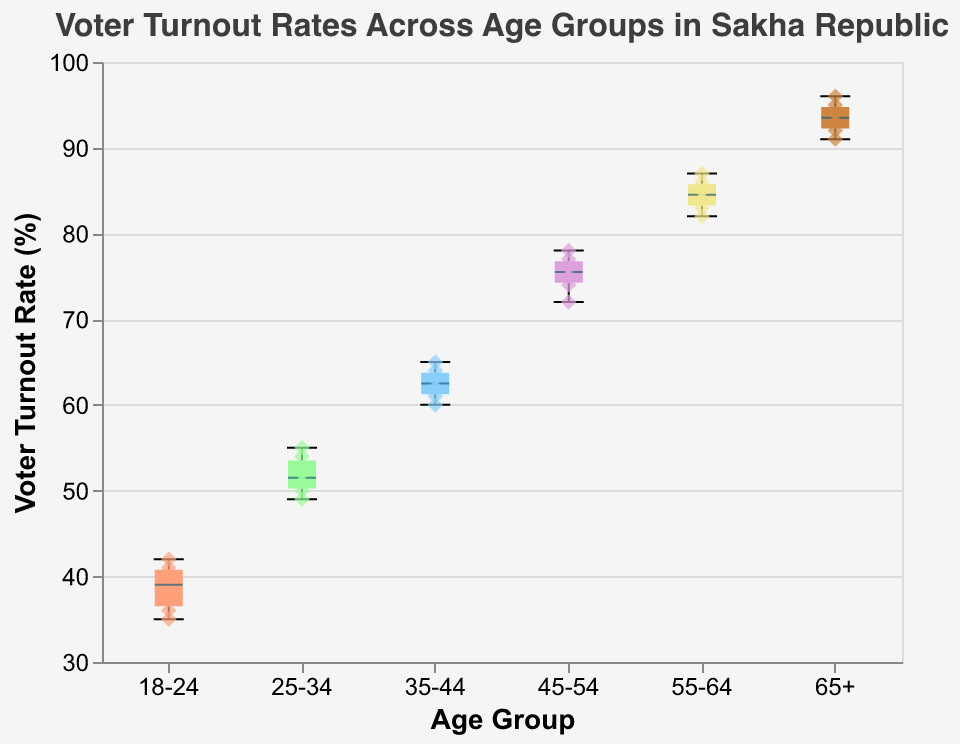What is the title of the figure? The title is located at the top of the figure and reads "Voter Turnout Rates Across Age Groups in Sakha Republic".
Answer: Voter Turnout Rates Across Age Groups in Sakha Republic What is the median voter turnout rate for the 25-34 age group? The median is represented by the horizontal line within the box for each age group. For the 25-34 age group, this line is at 51.
Answer: 51 Which age group has the highest median voter turnout rate? To find this, look at the horizontal lines within the boxes across all age groups. The age group 65+ has the highest median at 93.
Answer: 65+ What is the range of voter turnout rates for the 35-44 age group? The range is calculated by subtracting the minimum value within the boxplot (represented by the bottom whisker) from the maximum value (represented by the top whisker). For the 35-44 age group, the range is 65 - 60 = 5.
Answer: 5 How many data points are there for the 55-64 age group? There are 6 scatter points (i.e., diamond shapes) plotted within the range of the boxplot for the 55-64 age group, indicating 6 data points.
Answer: 6 Which age group shows the most variation in voter turnout rates? The most variation is indicated by the length of the box plot's whiskers and the box itself. The 65+ age group has the widest range from 91 to 96, indicating the most variation.
Answer: 65+ What is the lowest voter turnout rate for the 45-54 age group? The lowest turnout rate is indicated by the bottom whisker of the box plot for the 45-54 age group, which is positioned at 72.
Answer: 72 Calculate the interquartile range (IQR) for the 18-24 age group. The IQR is the range within the middle 50% of the data, found between the first quartile (bottom of the box) and the third quartile (top of the box). For the 18-24 age group, the IQR spans from 36 to 41, so the IQR is 41-36 = 5.
Answer: 5 Which age group has the highest voter turnout rate in any individual instance? The scatter points indicate individual instances. The highest point overall is for the 65+ age group at 96.
Answer: 65+ 